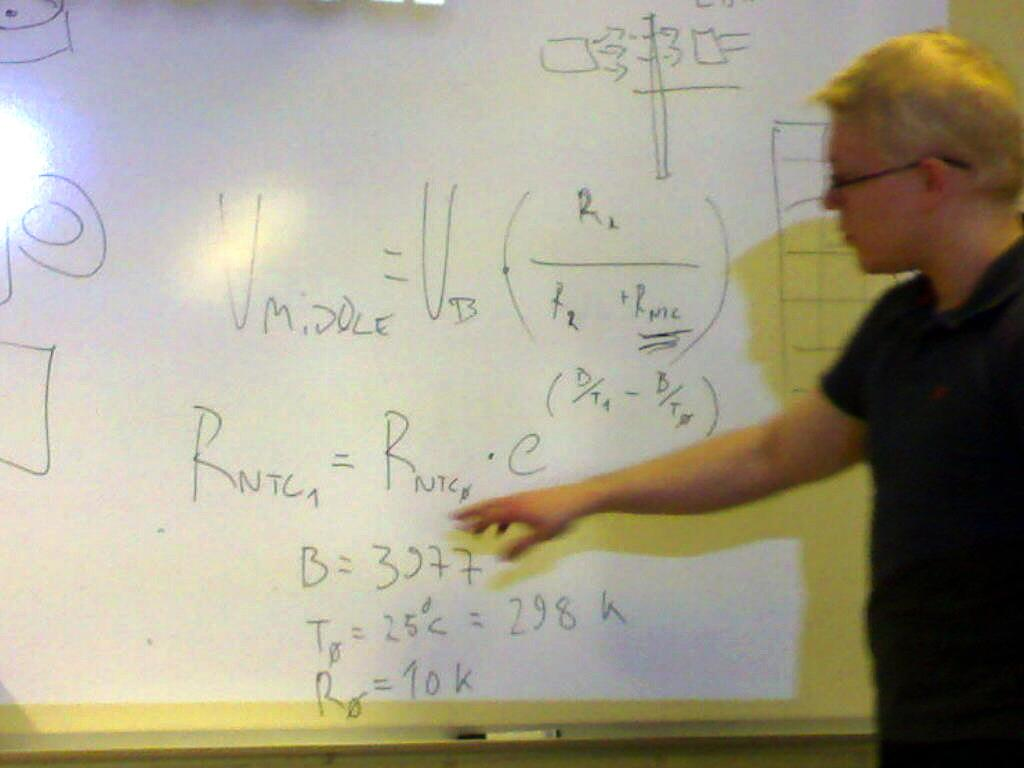<image>
Relay a brief, clear account of the picture shown. A man at a smart screen pointing to a formula containing B=3277. 